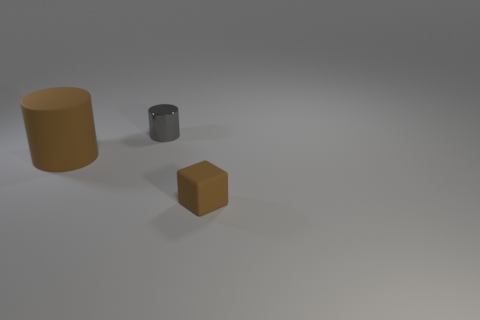Is the shape of the rubber object left of the small gray metal cylinder the same as the thing that is behind the big cylinder? yes 